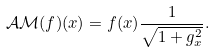Convert formula to latex. <formula><loc_0><loc_0><loc_500><loc_500>\mathcal { A M } ( f ) ( x ) = f ( x ) \frac { 1 } { \sqrt { 1 + g _ { x } ^ { 2 } } } .</formula> 